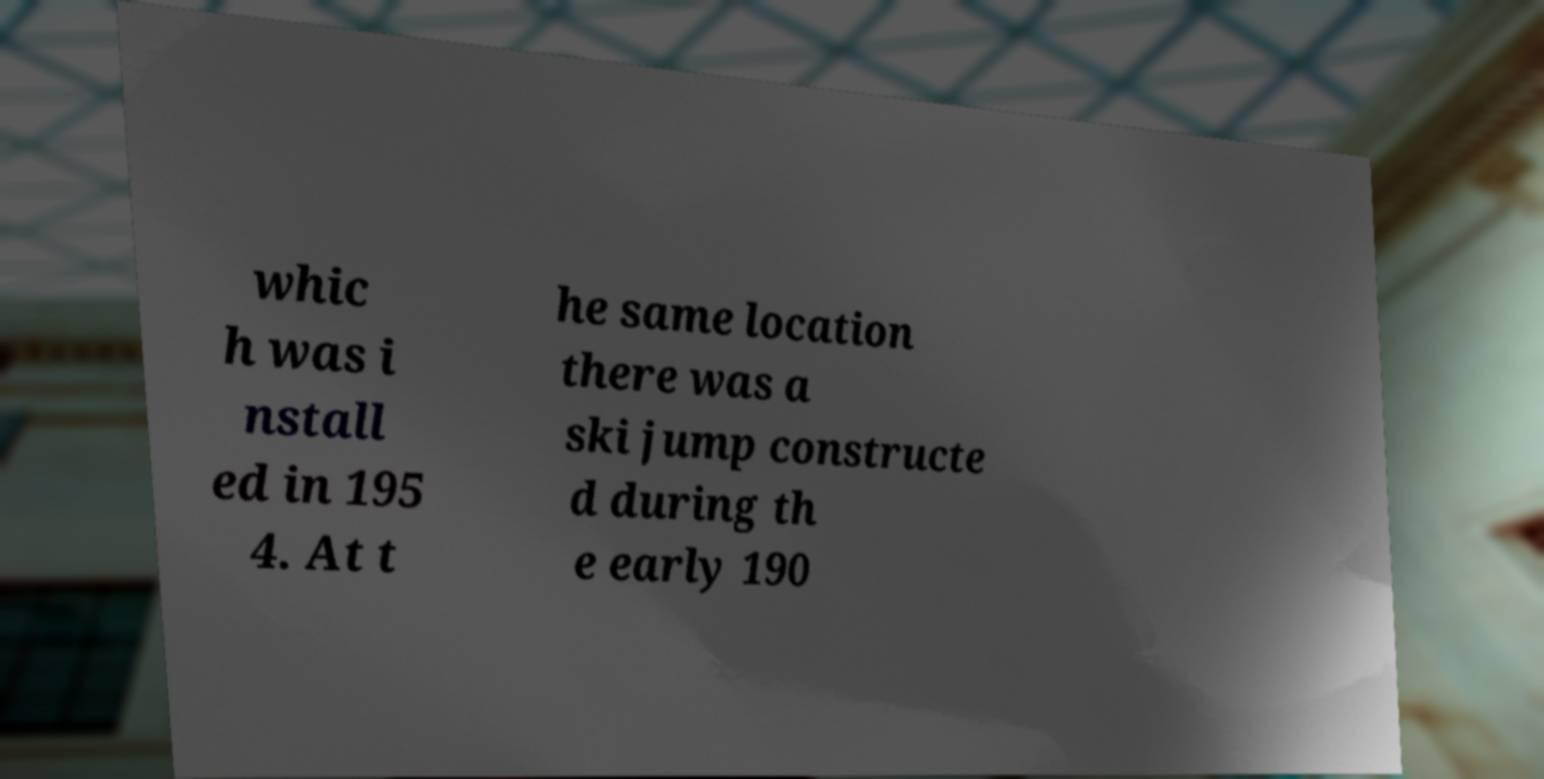What messages or text are displayed in this image? I need them in a readable, typed format. whic h was i nstall ed in 195 4. At t he same location there was a ski jump constructe d during th e early 190 